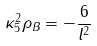Convert formula to latex. <formula><loc_0><loc_0><loc_500><loc_500>\kappa _ { 5 } ^ { 2 } \rho _ { B } = - \frac { 6 } { l ^ { 2 } }</formula> 